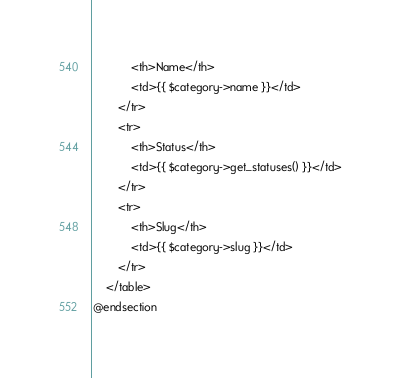Convert code to text. <code><loc_0><loc_0><loc_500><loc_500><_PHP_>            <th>Name</th>
            <td>{{ $category->name }}</td>
        </tr>
        <tr>
            <th>Status</th>
            <td>{{ $category->get_statuses() }}</td>
        </tr>
        <tr>
            <th>Slug</th>
            <td>{{ $category->slug }}</td>
        </tr>
    </table>
@endsection
</code> 